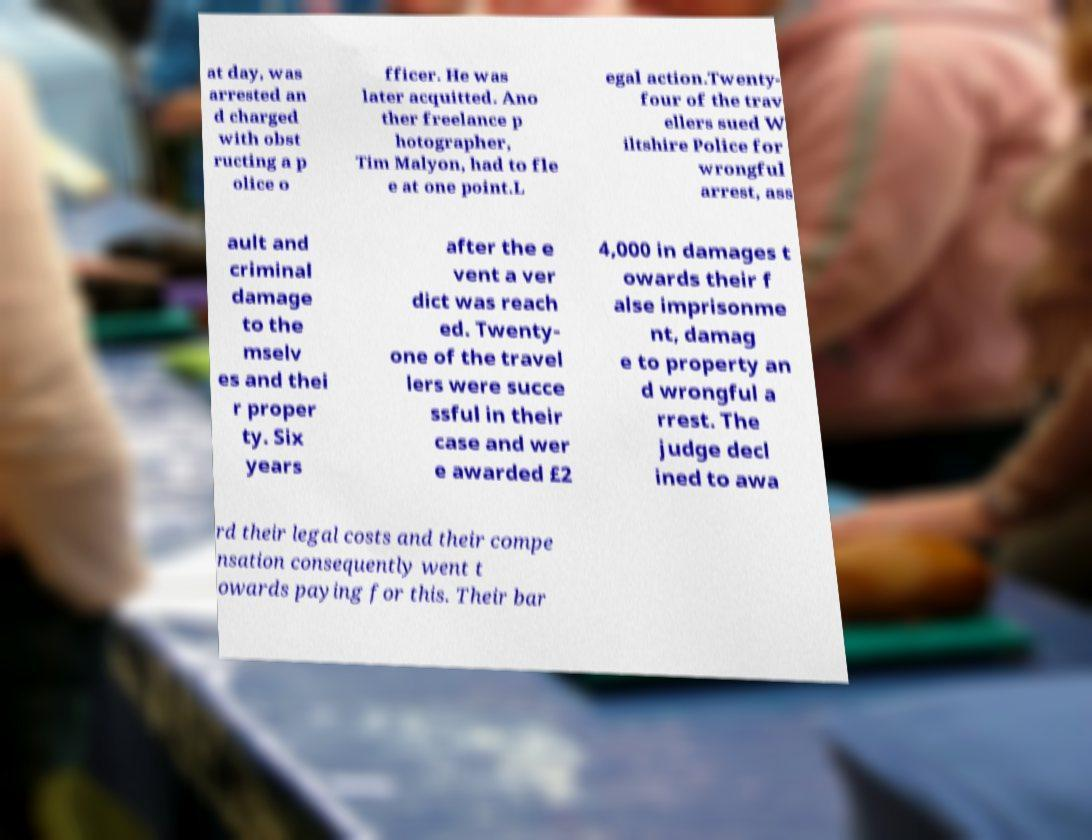Could you extract and type out the text from this image? at day, was arrested an d charged with obst ructing a p olice o fficer. He was later acquitted. Ano ther freelance p hotographer, Tim Malyon, had to fle e at one point.L egal action.Twenty- four of the trav ellers sued W iltshire Police for wrongful arrest, ass ault and criminal damage to the mselv es and thei r proper ty. Six years after the e vent a ver dict was reach ed. Twenty- one of the travel lers were succe ssful in their case and wer e awarded £2 4,000 in damages t owards their f alse imprisonme nt, damag e to property an d wrongful a rrest. The judge decl ined to awa rd their legal costs and their compe nsation consequently went t owards paying for this. Their bar 